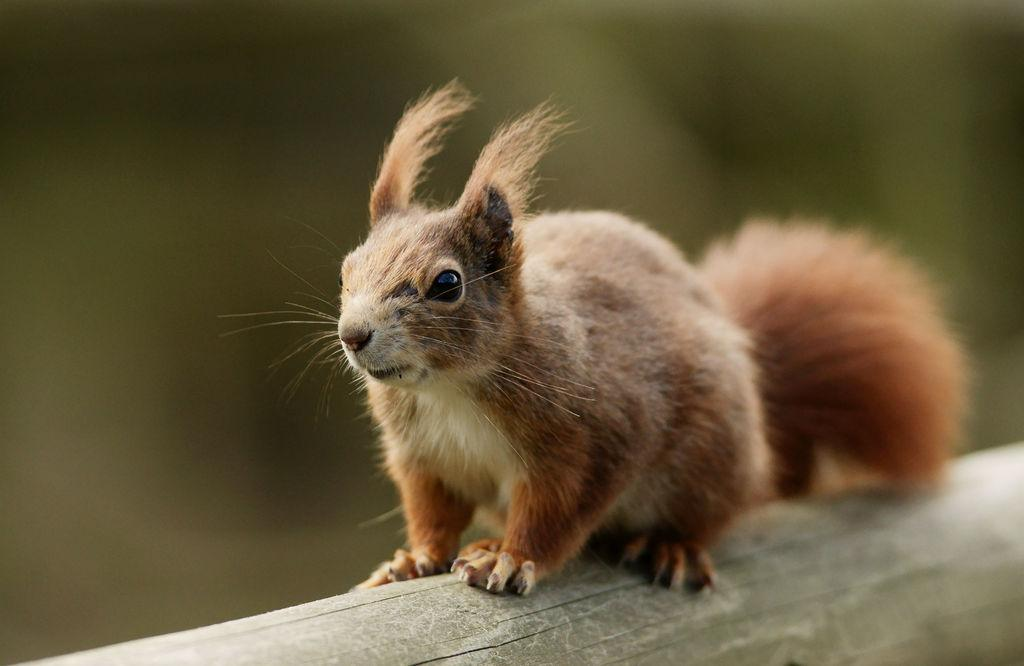What animal is present in the image? There is a squirrel in the image. Where is the squirrel located? The squirrel is on a wooden log. Can you describe the background of the image? The background of the image is blurry. What type of slope can be seen in the image? There is no slope present in the image; it features a squirrel on a wooden log with a blurry background. 